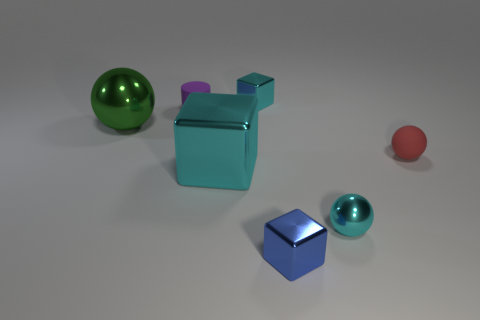What is the texture of the objects on the left compared to the one on the far right? The objects on the left appear to have a smooth, metallic texture, while the object on the far right has a matt, slightly rougher surface. 